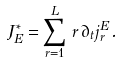<formula> <loc_0><loc_0><loc_500><loc_500>J _ { E } ^ { * } = \sum _ { r = 1 } ^ { L } \, r \, \partial _ { t } j ^ { E } _ { r } \, .</formula> 